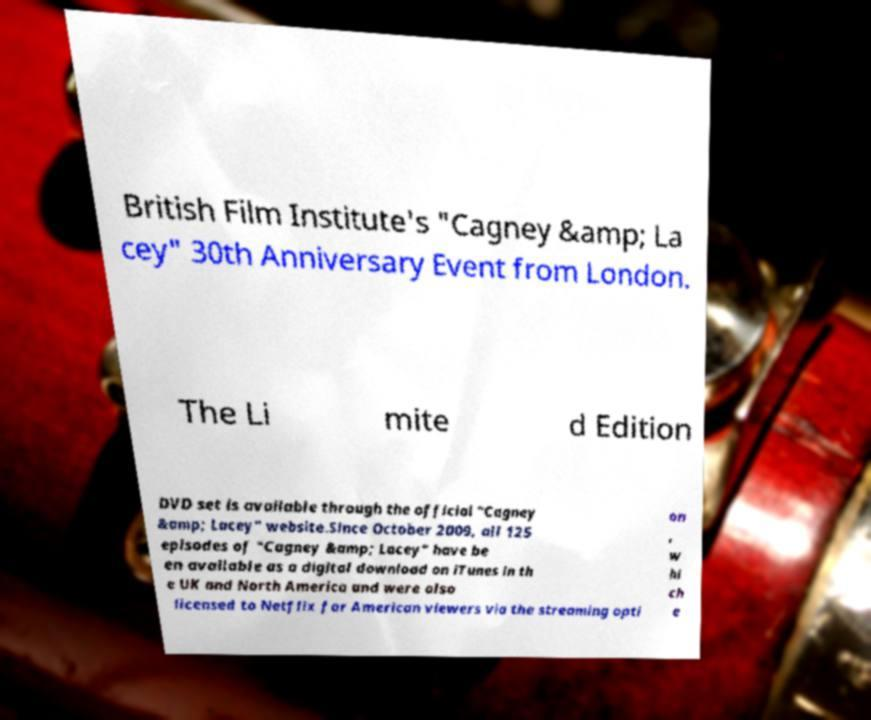Please identify and transcribe the text found in this image. British Film Institute's "Cagney &amp; La cey" 30th Anniversary Event from London. The Li mite d Edition DVD set is available through the official "Cagney &amp; Lacey" website.Since October 2009, all 125 episodes of "Cagney &amp; Lacey" have be en available as a digital download on iTunes in th e UK and North America and were also licensed to Netflix for American viewers via the streaming opti on , w hi ch e 